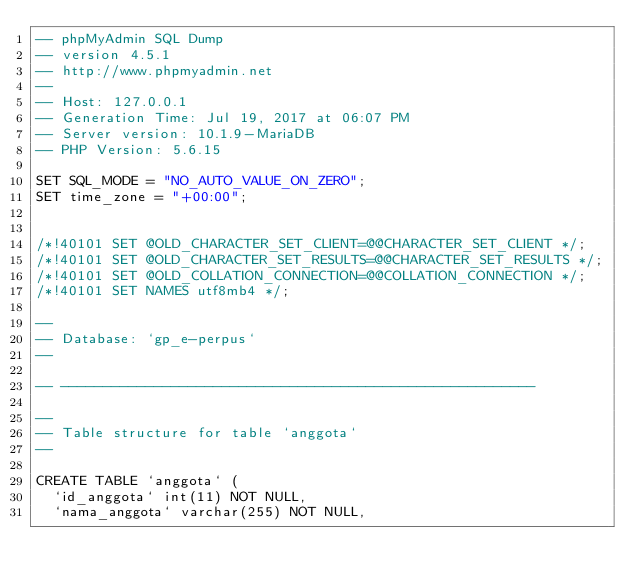Convert code to text. <code><loc_0><loc_0><loc_500><loc_500><_SQL_>-- phpMyAdmin SQL Dump
-- version 4.5.1
-- http://www.phpmyadmin.net
--
-- Host: 127.0.0.1
-- Generation Time: Jul 19, 2017 at 06:07 PM
-- Server version: 10.1.9-MariaDB
-- PHP Version: 5.6.15

SET SQL_MODE = "NO_AUTO_VALUE_ON_ZERO";
SET time_zone = "+00:00";


/*!40101 SET @OLD_CHARACTER_SET_CLIENT=@@CHARACTER_SET_CLIENT */;
/*!40101 SET @OLD_CHARACTER_SET_RESULTS=@@CHARACTER_SET_RESULTS */;
/*!40101 SET @OLD_COLLATION_CONNECTION=@@COLLATION_CONNECTION */;
/*!40101 SET NAMES utf8mb4 */;

--
-- Database: `gp_e-perpus`
--

-- --------------------------------------------------------

--
-- Table structure for table `anggota`
--

CREATE TABLE `anggota` (
  `id_anggota` int(11) NOT NULL,
  `nama_anggota` varchar(255) NOT NULL,</code> 